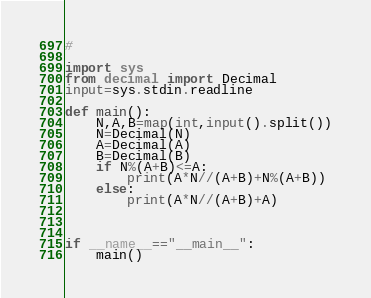<code> <loc_0><loc_0><loc_500><loc_500><_Python_>#

import sys
from decimal import Decimal
input=sys.stdin.readline

def main():
    N,A,B=map(int,input().split())
    N=Decimal(N)
    A=Decimal(A)
    B=Decimal(B)
    if N%(A+B)<=A:
        print(A*N//(A+B)+N%(A+B))
    else:
        print(A*N//(A+B)+A)
    
    
    
if __name__=="__main__":
    main()
</code> 